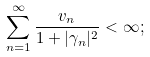Convert formula to latex. <formula><loc_0><loc_0><loc_500><loc_500>\sum _ { n = 1 } ^ { \infty } \frac { v _ { n } } { 1 + | \gamma _ { n } | ^ { 2 } } < \infty ;</formula> 